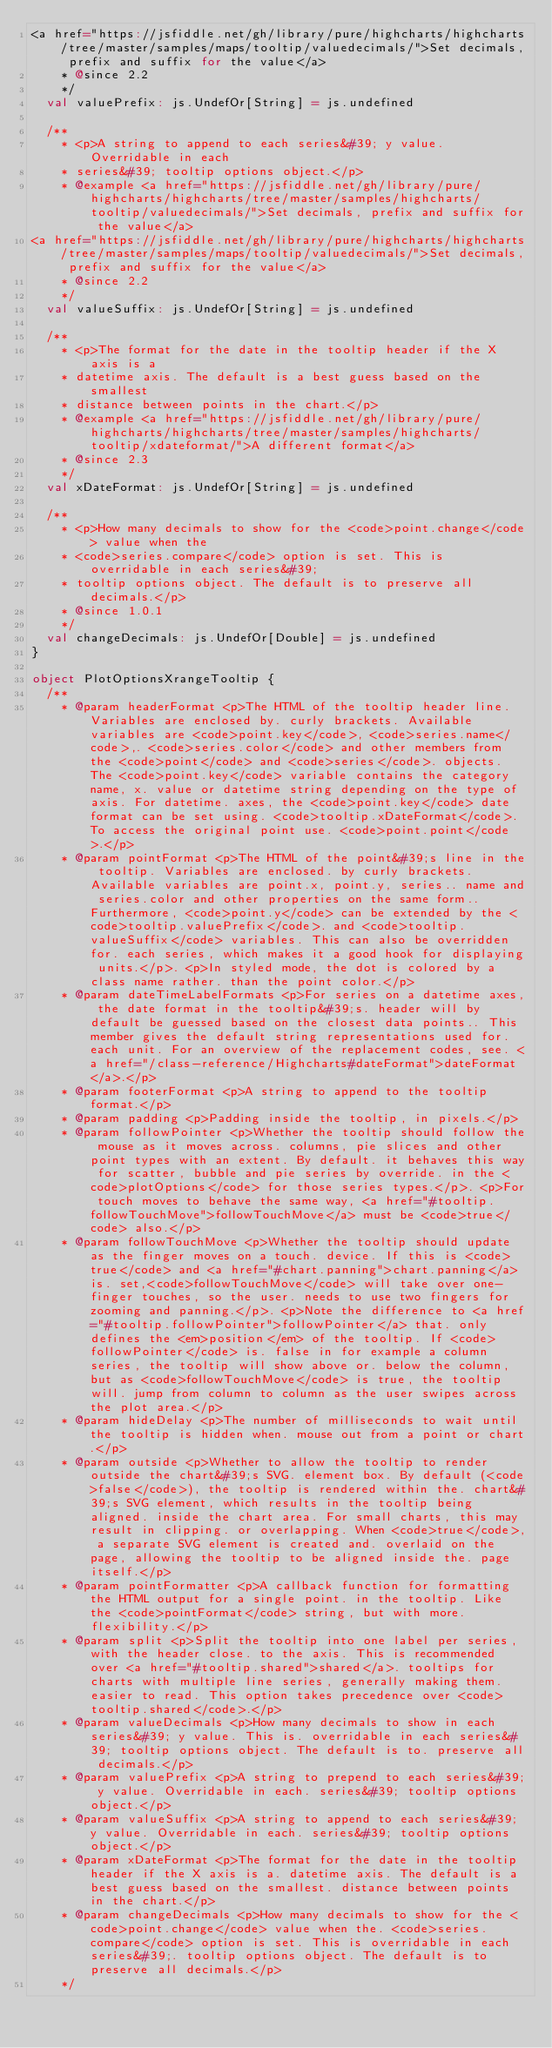Convert code to text. <code><loc_0><loc_0><loc_500><loc_500><_Scala_><a href="https://jsfiddle.net/gh/library/pure/highcharts/highcharts/tree/master/samples/maps/tooltip/valuedecimals/">Set decimals, prefix and suffix for the value</a>
    * @since 2.2
    */
  val valuePrefix: js.UndefOr[String] = js.undefined

  /**
    * <p>A string to append to each series&#39; y value. Overridable in each
    * series&#39; tooltip options object.</p>
    * @example <a href="https://jsfiddle.net/gh/library/pure/highcharts/highcharts/tree/master/samples/highcharts/tooltip/valuedecimals/">Set decimals, prefix and suffix for the value</a>
<a href="https://jsfiddle.net/gh/library/pure/highcharts/highcharts/tree/master/samples/maps/tooltip/valuedecimals/">Set decimals, prefix and suffix for the value</a>
    * @since 2.2
    */
  val valueSuffix: js.UndefOr[String] = js.undefined

  /**
    * <p>The format for the date in the tooltip header if the X axis is a
    * datetime axis. The default is a best guess based on the smallest
    * distance between points in the chart.</p>
    * @example <a href="https://jsfiddle.net/gh/library/pure/highcharts/highcharts/tree/master/samples/highcharts/tooltip/xdateformat/">A different format</a>
    * @since 2.3
    */
  val xDateFormat: js.UndefOr[String] = js.undefined

  /**
    * <p>How many decimals to show for the <code>point.change</code> value when the
    * <code>series.compare</code> option is set. This is overridable in each series&#39;
    * tooltip options object. The default is to preserve all decimals.</p>
    * @since 1.0.1
    */
  val changeDecimals: js.UndefOr[Double] = js.undefined
}

object PlotOptionsXrangeTooltip {
  /**
    * @param headerFormat <p>The HTML of the tooltip header line. Variables are enclosed by. curly brackets. Available variables are <code>point.key</code>, <code>series.name</code>,. <code>series.color</code> and other members from the <code>point</code> and <code>series</code>. objects. The <code>point.key</code> variable contains the category name, x. value or datetime string depending on the type of axis. For datetime. axes, the <code>point.key</code> date format can be set using. <code>tooltip.xDateFormat</code>. To access the original point use. <code>point.point</code>.</p>
    * @param pointFormat <p>The HTML of the point&#39;s line in the tooltip. Variables are enclosed. by curly brackets. Available variables are point.x, point.y, series.. name and series.color and other properties on the same form.. Furthermore, <code>point.y</code> can be extended by the <code>tooltip.valuePrefix</code>. and <code>tooltip.valueSuffix</code> variables. This can also be overridden for. each series, which makes it a good hook for displaying units.</p>. <p>In styled mode, the dot is colored by a class name rather. than the point color.</p>
    * @param dateTimeLabelFormats <p>For series on a datetime axes, the date format in the tooltip&#39;s. header will by default be guessed based on the closest data points.. This member gives the default string representations used for. each unit. For an overview of the replacement codes, see. <a href="/class-reference/Highcharts#dateFormat">dateFormat</a>.</p>
    * @param footerFormat <p>A string to append to the tooltip format.</p>
    * @param padding <p>Padding inside the tooltip, in pixels.</p>
    * @param followPointer <p>Whether the tooltip should follow the mouse as it moves across. columns, pie slices and other point types with an extent. By default. it behaves this way for scatter, bubble and pie series by override. in the <code>plotOptions</code> for those series types.</p>. <p>For touch moves to behave the same way, <a href="#tooltip.followTouchMove">followTouchMove</a> must be <code>true</code> also.</p>
    * @param followTouchMove <p>Whether the tooltip should update as the finger moves on a touch. device. If this is <code>true</code> and <a href="#chart.panning">chart.panning</a> is. set,<code>followTouchMove</code> will take over one-finger touches, so the user. needs to use two fingers for zooming and panning.</p>. <p>Note the difference to <a href="#tooltip.followPointer">followPointer</a> that. only defines the <em>position</em> of the tooltip. If <code>followPointer</code> is. false in for example a column series, the tooltip will show above or. below the column, but as <code>followTouchMove</code> is true, the tooltip will. jump from column to column as the user swipes across the plot area.</p>
    * @param hideDelay <p>The number of milliseconds to wait until the tooltip is hidden when. mouse out from a point or chart.</p>
    * @param outside <p>Whether to allow the tooltip to render outside the chart&#39;s SVG. element box. By default (<code>false</code>), the tooltip is rendered within the. chart&#39;s SVG element, which results in the tooltip being aligned. inside the chart area. For small charts, this may result in clipping. or overlapping. When <code>true</code>, a separate SVG element is created and. overlaid on the page, allowing the tooltip to be aligned inside the. page itself.</p>
    * @param pointFormatter <p>A callback function for formatting the HTML output for a single point. in the tooltip. Like the <code>pointFormat</code> string, but with more. flexibility.</p>
    * @param split <p>Split the tooltip into one label per series, with the header close. to the axis. This is recommended over <a href="#tooltip.shared">shared</a>. tooltips for charts with multiple line series, generally making them. easier to read. This option takes precedence over <code>tooltip.shared</code>.</p>
    * @param valueDecimals <p>How many decimals to show in each series&#39; y value. This is. overridable in each series&#39; tooltip options object. The default is to. preserve all decimals.</p>
    * @param valuePrefix <p>A string to prepend to each series&#39; y value. Overridable in each. series&#39; tooltip options object.</p>
    * @param valueSuffix <p>A string to append to each series&#39; y value. Overridable in each. series&#39; tooltip options object.</p>
    * @param xDateFormat <p>The format for the date in the tooltip header if the X axis is a. datetime axis. The default is a best guess based on the smallest. distance between points in the chart.</p>
    * @param changeDecimals <p>How many decimals to show for the <code>point.change</code> value when the. <code>series.compare</code> option is set. This is overridable in each series&#39;. tooltip options object. The default is to preserve all decimals.</p>
    */</code> 